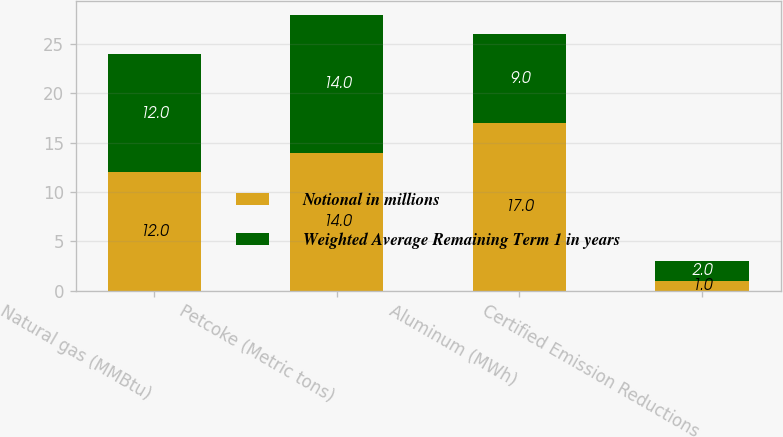Convert chart to OTSL. <chart><loc_0><loc_0><loc_500><loc_500><stacked_bar_chart><ecel><fcel>Natural gas (MMBtu)<fcel>Petcoke (Metric tons)<fcel>Aluminum (MWh)<fcel>Certified Emission Reductions<nl><fcel>Notional in millions<fcel>12<fcel>14<fcel>17<fcel>1<nl><fcel>Weighted Average Remaining Term 1 in years<fcel>12<fcel>14<fcel>9<fcel>2<nl></chart> 